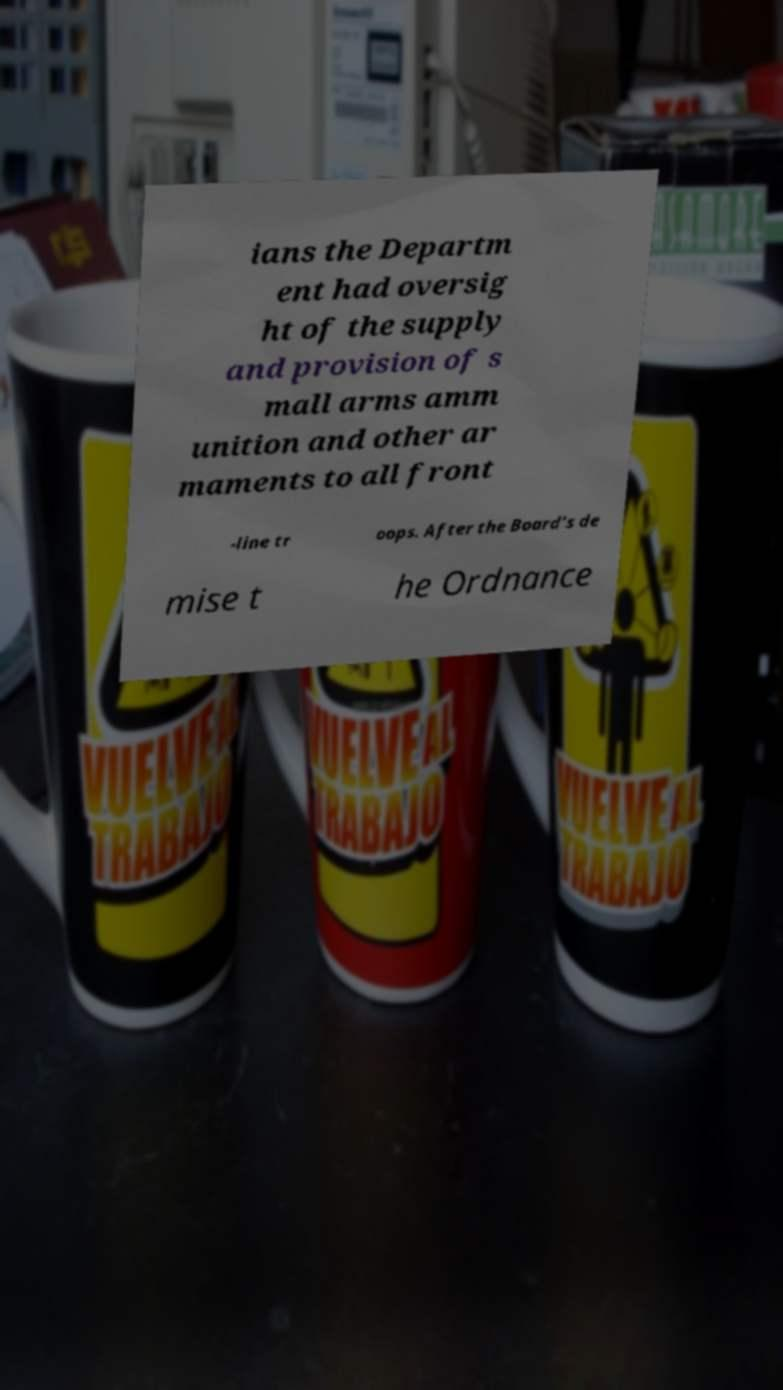What messages or text are displayed in this image? I need them in a readable, typed format. ians the Departm ent had oversig ht of the supply and provision of s mall arms amm unition and other ar maments to all front -line tr oops. After the Board's de mise t he Ordnance 